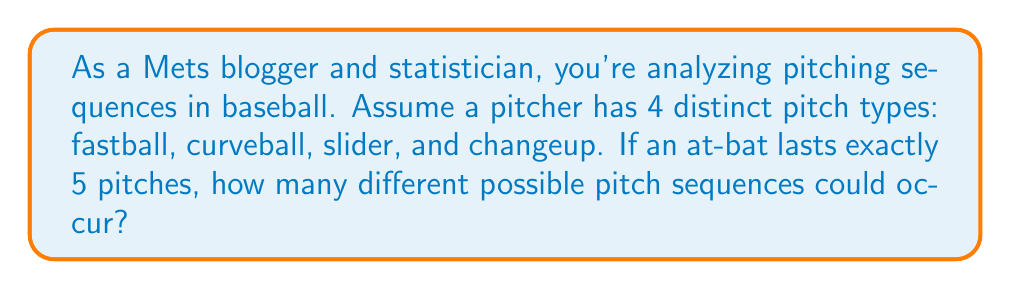What is the answer to this math problem? To solve this problem, we need to use the multiplication principle of counting. Here's the step-by-step explanation:

1) For each pitch in the sequence, the pitcher has 4 choices (fastball, curveball, slider, or changeup).

2) The sequence consists of exactly 5 pitches.

3) For each pitch, the choice is independent of the previous pitches.

4) We can represent this scenario mathematically as:

   $$\text{Number of sequences} = 4 \times 4 \times 4 \times 4 \times 4$$

   This is because:
   - For the first pitch, there are 4 choices
   - For the second pitch, there are again 4 choices
   - This continues for all 5 pitches

5) We can simplify this expression as:

   $$\text{Number of sequences} = 4^5$$

6) Calculate the result:

   $$4^5 = 4 \times 4 \times 4 \times 4 \times 4 = 1024$$

Therefore, there are 1024 different possible pitch sequences in an at-bat lasting exactly 5 pitches.
Answer: $1024$ distinct pitching sequences 